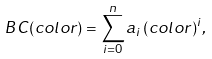Convert formula to latex. <formula><loc_0><loc_0><loc_500><loc_500>B C ( c o l o r ) = \sum _ { i = 0 } ^ { n } a _ { i } \, ( c o l o r ) ^ { i } ,</formula> 